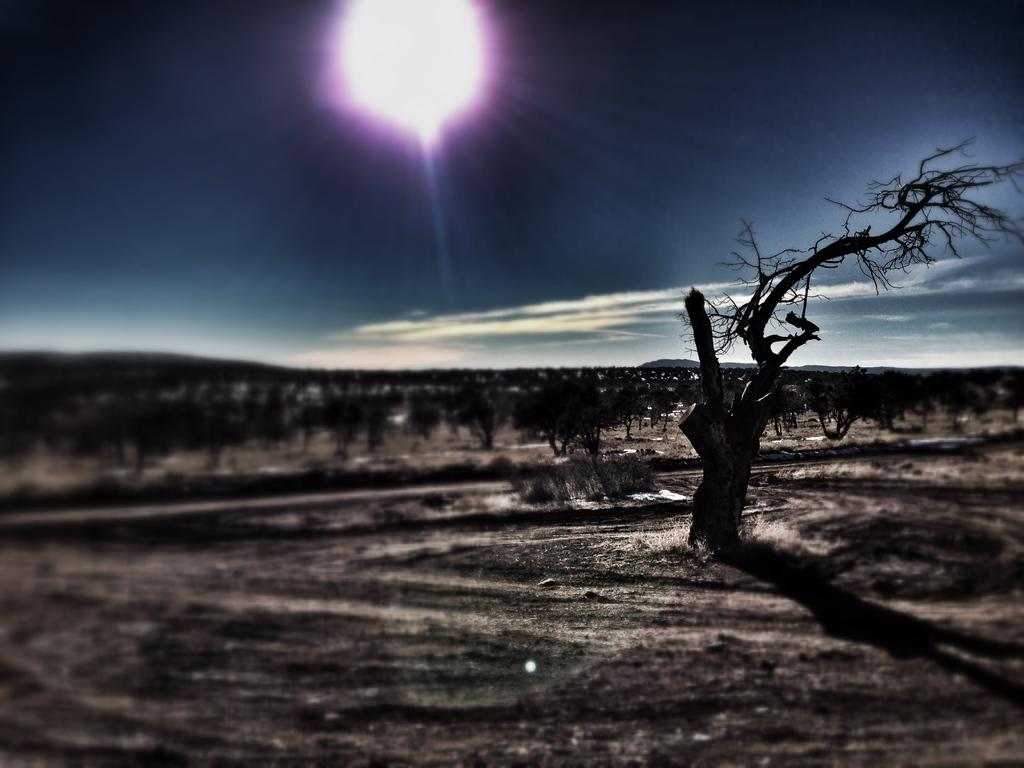What is the main object in the foreground of the image? There is a tree in the image. What can be seen in the background of the image? There are many trees in the background of the image. What part of the natural environment is visible in the image? The sky is visible in the image. What celestial body can be seen in the sky? The moon is present in the sky. What type of alarm can be heard going off in the image? There is no alarm present or audible in the image. How many snakes are slithering around the tree in the image? There are no snakes present in the image. What type of vegetable is growing on the tree in the image? There are no vegetables, including tomatoes, growing on the tree in the image. 